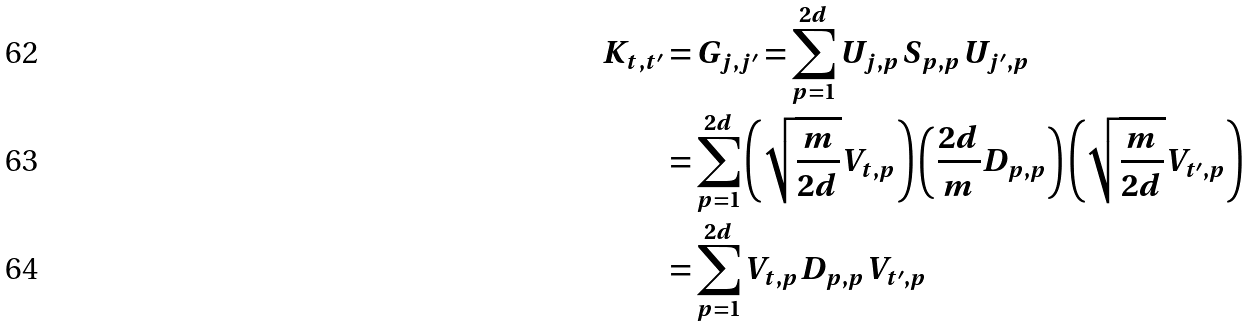Convert formula to latex. <formula><loc_0><loc_0><loc_500><loc_500>K _ { t , t ^ { \prime } } & = G _ { j , j ^ { \prime } } = \sum _ { p = 1 } ^ { 2 d } U _ { j , p } S _ { p , p } U _ { j ^ { \prime } , p } \\ & = \sum _ { p = 1 } ^ { 2 d } \left ( \sqrt { \frac { m } { 2 d } } V _ { t , p } \right ) \left ( \frac { 2 d } { m } D _ { p , p } \right ) \left ( \sqrt { \frac { m } { 2 d } } V _ { t ^ { \prime } , p } \right ) \\ & = \sum _ { p = 1 } ^ { 2 d } V _ { t , p } D _ { p , p } V _ { t ^ { \prime } , p }</formula> 